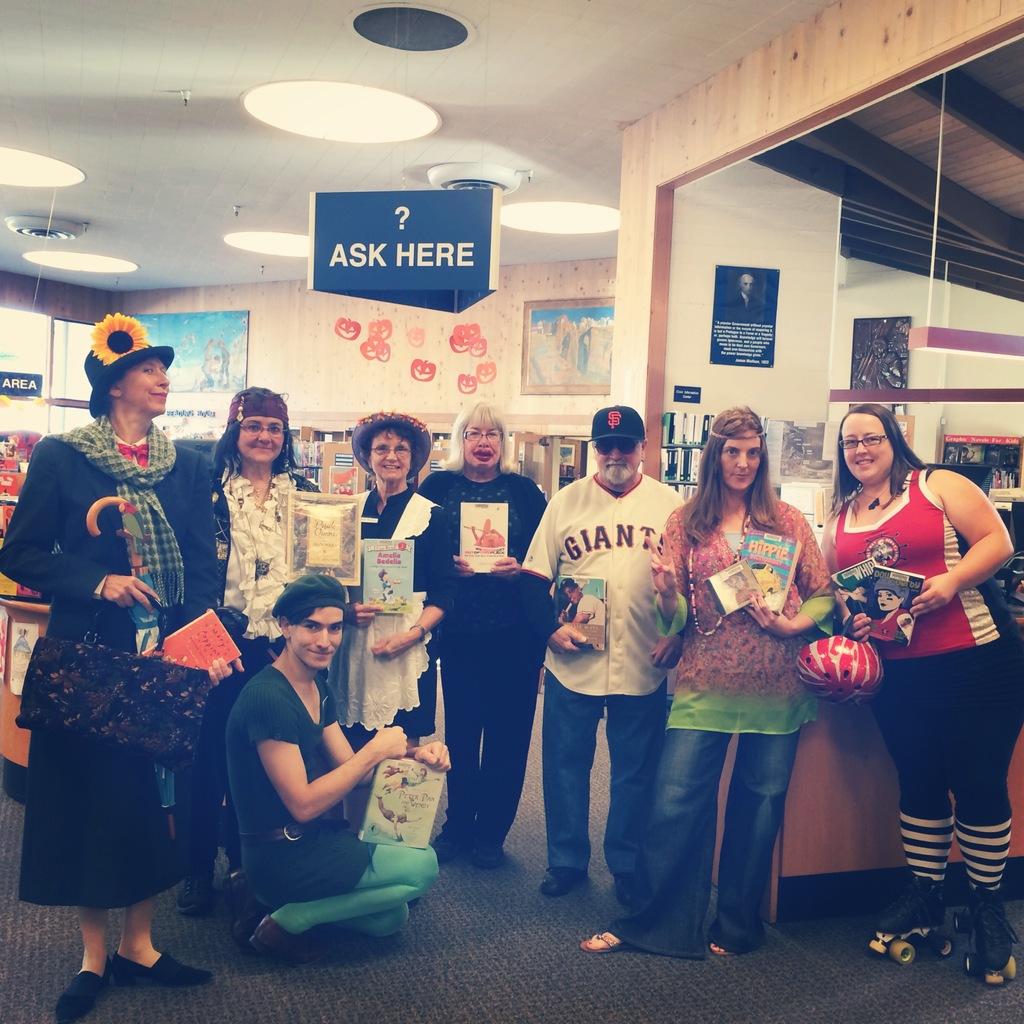What baseball team is on the man's jersey?
Provide a succinct answer. Giants. 